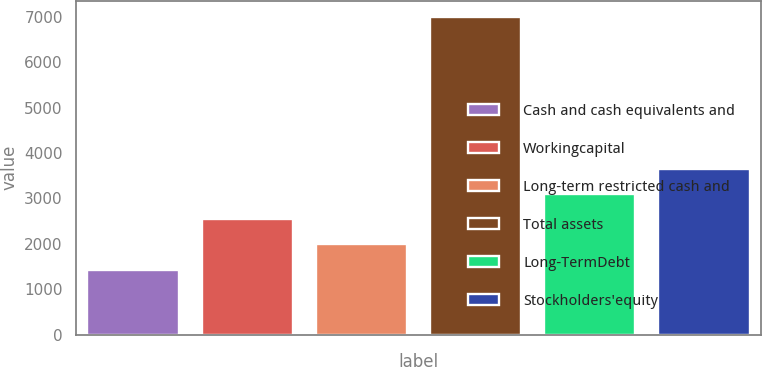Convert chart. <chart><loc_0><loc_0><loc_500><loc_500><bar_chart><fcel>Cash and cash equivalents and<fcel>Workingcapital<fcel>Long-term restricted cash and<fcel>Total assets<fcel>Long-TermDebt<fcel>Stockholders'equity<nl><fcel>1429<fcel>2544.6<fcel>1986.8<fcel>7007<fcel>3102.4<fcel>3660.2<nl></chart> 